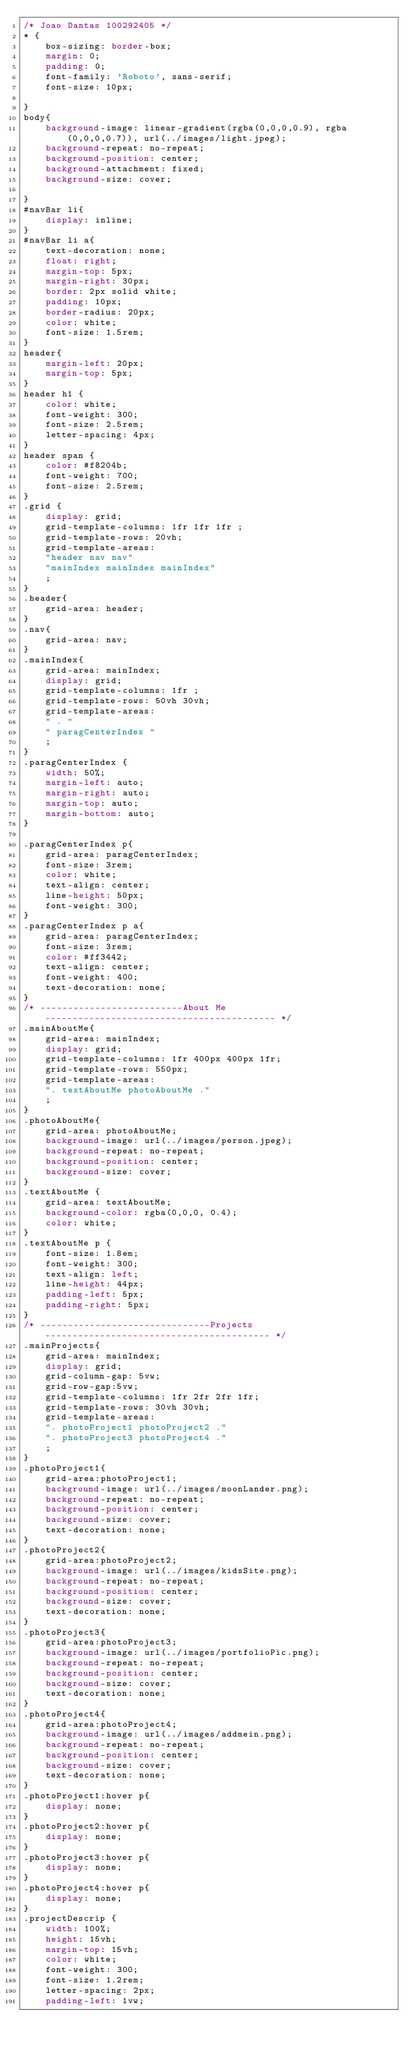<code> <loc_0><loc_0><loc_500><loc_500><_CSS_>/* Joao Dantas 100292405 */
* {
    box-sizing: border-box;
    margin: 0;
    padding: 0;
    font-family: 'Roboto', sans-serif;
    font-size: 10px;

}
body{
    background-image: linear-gradient(rgba(0,0,0,0.9), rgba(0,0,0,0.7)), url(../images/light.jpeg);
    background-repeat: no-repeat;
    background-position: center;
    background-attachment: fixed;
    background-size: cover;
    
}
#navBar li{
    display: inline;
}
#navBar li a{
    text-decoration: none;
    float: right;
    margin-top: 5px;
    margin-right: 30px;
    border: 2px solid white;
    padding: 10px;
    border-radius: 20px;
    color: white;
    font-size: 1.5rem;
}
header{
    margin-left: 20px;
    margin-top: 5px;
}
header h1 {
    color: white;
    font-weight: 300;
    font-size: 2.5rem;
    letter-spacing: 4px;
}
header span {
    color: #f8204b;
    font-weight: 700;
    font-size: 2.5rem;
}
.grid {
    display: grid;
    grid-template-columns: 1fr 1fr 1fr ;
    grid-template-rows: 20vh;
    grid-template-areas: 
    "header nav nav"
    "mainIndex mainIndex mainIndex"
    ;
}
.header{
    grid-area: header;
}
.nav{
    grid-area: nav;   
}
.mainIndex{
    grid-area: mainIndex;
    display: grid;
    grid-template-columns: 1fr ;
    grid-template-rows: 50vh 30vh;
    grid-template-areas: 
    " . "
    " paragCenterIndex "
    ;
}
.paragCenterIndex {
    width: 50%;
    margin-left: auto;
    margin-right: auto;
    margin-top: auto;
    margin-bottom: auto;
}

.paragCenterIndex p{
    grid-area: paragCenterIndex;
    font-size: 3rem;
    color: white;
    text-align: center;
    line-height: 50px;
    font-weight: 300; 
}
.paragCenterIndex p a{
    grid-area: paragCenterIndex;
    font-size: 3rem;
    color: #ff3442;
    text-align: center;
    font-weight: 400; 
    text-decoration: none;
}
/* --------------------------About Me------------------------------------------ */
.mainAboutMe{
    grid-area: mainIndex;
    display: grid;
    grid-template-columns: 1fr 400px 400px 1fr;
    grid-template-rows: 550px;
    grid-template-areas: 
    ". textAboutMe photoAboutMe ."
    ;
}
.photoAboutMe{
    grid-area: photoAboutMe;
    background-image: url(../images/person.jpeg);
    background-repeat: no-repeat;
    background-position: center;
    background-size: cover;
}
.textAboutMe {
    grid-area: textAboutMe;
    background-color: rgba(0,0,0, 0.4);
    color: white;
}
.textAboutMe p {
    font-size: 1.8em;
    font-weight: 300;
    text-align: left;
    line-height: 44px;
    padding-left: 5px;
    padding-right: 5px;
}
/* -------------------------------Projects----------------------------------------- */
.mainProjects{
    grid-area: mainIndex;
    display: grid;
    grid-column-gap: 5vw;
    grid-row-gap:5vw;
    grid-template-columns: 1fr 2fr 2fr 1fr;
    grid-template-rows: 30vh 30vh;
    grid-template-areas: 
    ". photoProject1 photoProject2 ."
    ". photoProject3 photoProject4 ."
    ;
}
.photoProject1{
    grid-area:photoProject1;
    background-image: url(../images/moonLander.png); 
    background-repeat: no-repeat;
    background-position: center;
    background-size: cover;
    text-decoration: none;
}
.photoProject2{
    grid-area:photoProject2; 
    background-image: url(../images/kidsSite.png); 
    background-repeat: no-repeat;
    background-position: center;
    background-size: cover;
    text-decoration: none;
}
.photoProject3{
    grid-area:photoProject3; 
    background-image: url(../images/portfolioPic.png); 
    background-repeat: no-repeat;
    background-position: center;
    background-size: cover;
    text-decoration: none;
}
.photoProject4{
    grid-area:photoProject4; 
    background-image: url(../images/addmein.png); 
    background-repeat: no-repeat;
    background-position: center;
    background-size: cover;
    text-decoration: none;
}
.photoProject1:hover p{
    display: none;
}
.photoProject2:hover p{
    display: none;
}
.photoProject3:hover p{
    display: none;
}
.photoProject4:hover p{
    display: none;  
}
.projectDescrip {
    width: 100%;
    height: 15vh;
    margin-top: 15vh;
    color: white;
    font-weight: 300;
    font-size: 1.2rem;
    letter-spacing: 2px;
    padding-left: 1vw;</code> 